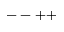Convert formula to latex. <formula><loc_0><loc_0><loc_500><loc_500>- - + +</formula> 